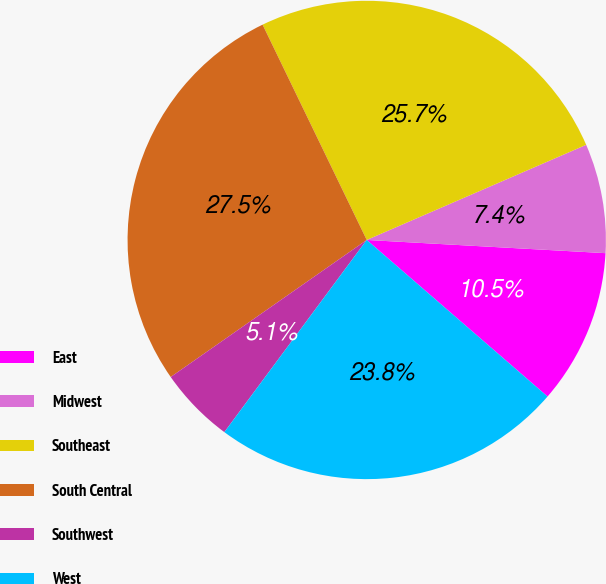Convert chart. <chart><loc_0><loc_0><loc_500><loc_500><pie_chart><fcel>East<fcel>Midwest<fcel>Southeast<fcel>South Central<fcel>Southwest<fcel>West<nl><fcel>10.48%<fcel>7.39%<fcel>25.66%<fcel>27.54%<fcel>5.14%<fcel>23.79%<nl></chart> 